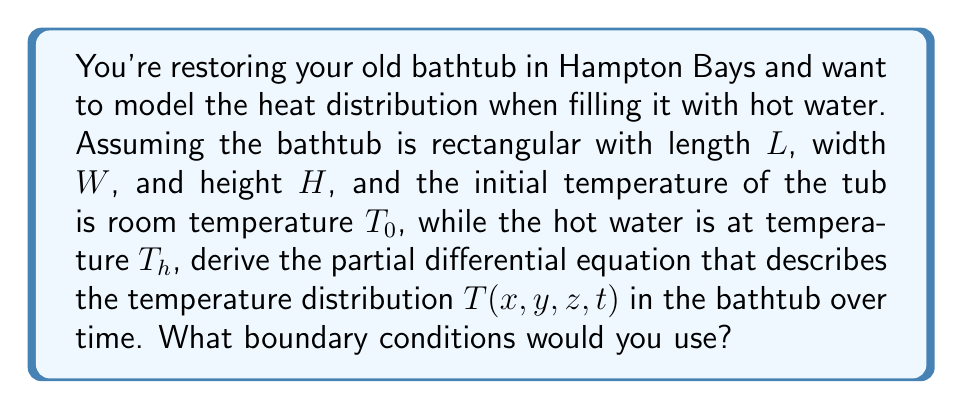Provide a solution to this math problem. To model the heat distribution in the bathtub, we need to use the heat equation, a partial differential equation that describes how the temperature of a system changes over time. The general form of the heat equation in three dimensions is:

$$\frac{\partial T}{\partial t} = \alpha \left(\frac{\partial^2 T}{\partial x^2} + \frac{\partial^2 T}{\partial y^2} + \frac{\partial^2 T}{\partial z^2}\right)$$

Where:
- $T(x,y,z,t)$ is the temperature at position $(x,y,z)$ and time $t$
- $\alpha$ is the thermal diffusivity of water

For the boundary conditions:

1. Initial condition: At $t=0$, the temperature of the tub is room temperature:
   $$T(x,y,z,0) = T_0 \quad \text{for all } x,y,z$$

2. Boundary conditions:
   - At the water surface $(z=H)$: We can assume the temperature is constant and equal to the hot water temperature:
     $$T(x,y,H,t) = T_h \quad \text{for all } x,y,t$$
   - At the walls and bottom of the tub $(x=0, x=L, y=0, y=W, z=0)$: We can assume insulated conditions (no heat flux):
     $$\frac{\partial T}{\partial x}(0,y,z,t) = \frac{\partial T}{\partial x}(L,y,z,t) = 0$$
     $$\frac{\partial T}{\partial y}(x,0,z,t) = \frac{\partial T}{\partial y}(x,W,z,t) = 0$$
     $$\frac{\partial T}{\partial z}(x,y,0,t) = 0$$

These equations together form a complete model of the heat distribution in the bathtub.
Answer: The partial differential equation describing the temperature distribution is:

$$\frac{\partial T}{\partial t} = \alpha \left(\frac{\partial^2 T}{\partial x^2} + \frac{\partial^2 T}{\partial y^2} + \frac{\partial^2 T}{\partial z^2}\right)$$

With boundary conditions:
1. $T(x,y,z,0) = T_0$
2. $T(x,y,H,t) = T_h$
3. $\frac{\partial T}{\partial x}(0,y,z,t) = \frac{\partial T}{\partial x}(L,y,z,t) = 0$
4. $\frac{\partial T}{\partial y}(x,0,z,t) = \frac{\partial T}{\partial y}(x,W,z,t) = 0$
5. $\frac{\partial T}{\partial z}(x,y,0,t) = 0$ 